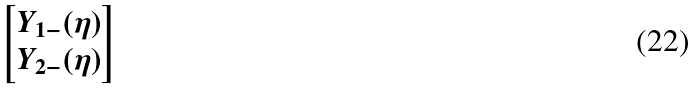<formula> <loc_0><loc_0><loc_500><loc_500>\begin{bmatrix} Y _ { 1 - } ( \eta ) \\ Y _ { 2 - } ( \eta ) \end{bmatrix}</formula> 